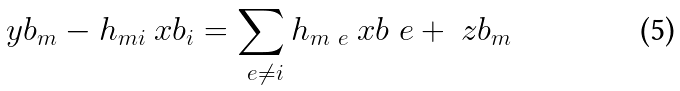<formula> <loc_0><loc_0><loc_500><loc_500>\ y b _ { m } - h _ { m i } \ x b _ { i } = \sum _ { \ e \neq i } { h _ { m \ e } \ x b _ { \ } e + \ z b _ { m } }</formula> 